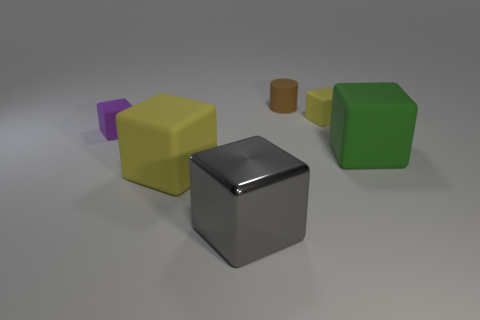Subtract all green balls. How many yellow blocks are left? 2 Subtract 3 blocks. How many blocks are left? 2 Subtract all gray blocks. How many blocks are left? 4 Subtract all small yellow blocks. How many blocks are left? 4 Add 1 large brown rubber balls. How many objects exist? 7 Subtract all red cubes. Subtract all blue spheres. How many cubes are left? 5 Subtract all blocks. How many objects are left? 1 Subtract 1 green cubes. How many objects are left? 5 Subtract all yellow objects. Subtract all purple rubber blocks. How many objects are left? 3 Add 2 big objects. How many big objects are left? 5 